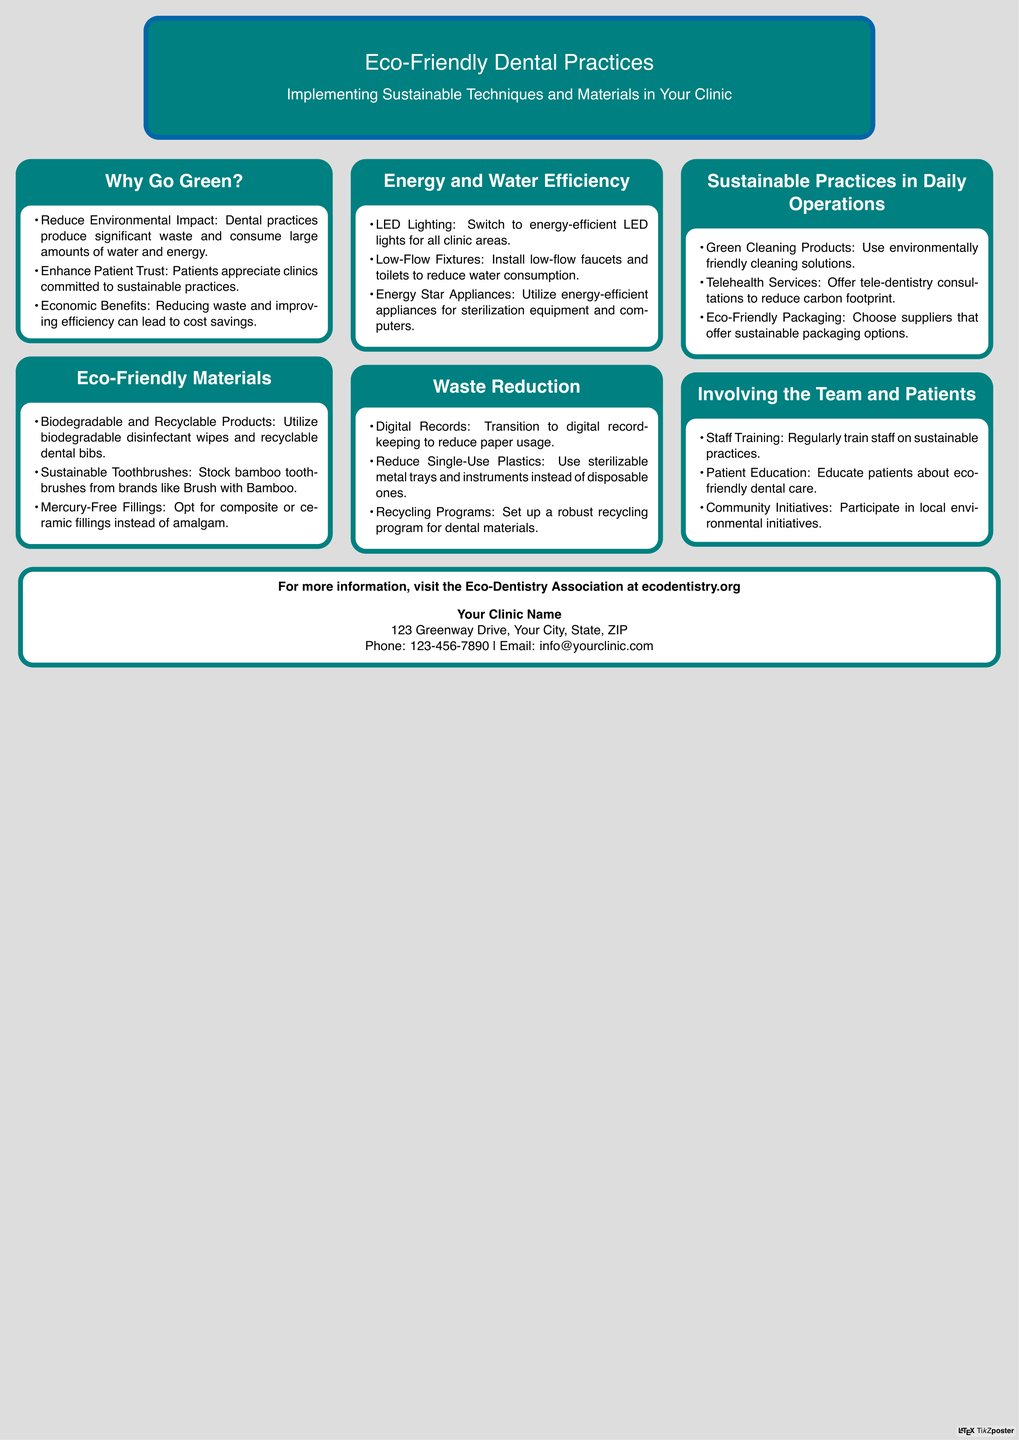What are two benefits of going green? The document lists benefits such as reducing environmental impact and enhancing patient trust.
Answer: Reduce environmental impact, enhance patient trust What type of toothbrush is recommended? The document recommends stocking bamboo toothbrushes from brands like Brush with Bamboo.
Answer: Bamboo toothbrushes Which lighting type is suggested for energy efficiency? The document suggests switching to energy-efficient LED lights for all clinic areas.
Answer: LED lighting What is one method to reduce paper usage? The document suggests transitioning to digital record-keeping.
Answer: Digital records How can clinics educate patients about eco-friendly practices? The document mentions patient education about eco-friendly dental care as a way to involve them.
Answer: Patient education What is a waste reduction technique mentioned? The document discusses using sterilizable metal trays and instruments instead of disposable ones.
Answer: Sterilizable metal trays What type of cleaning products should be used? The document advises using environmentally friendly cleaning solutions.
Answer: Green cleaning products What is a sustainable practice in daily operations? The document includes offering tele-dentistry consultations to reduce carbon footprint.
Answer: Telehealth services 